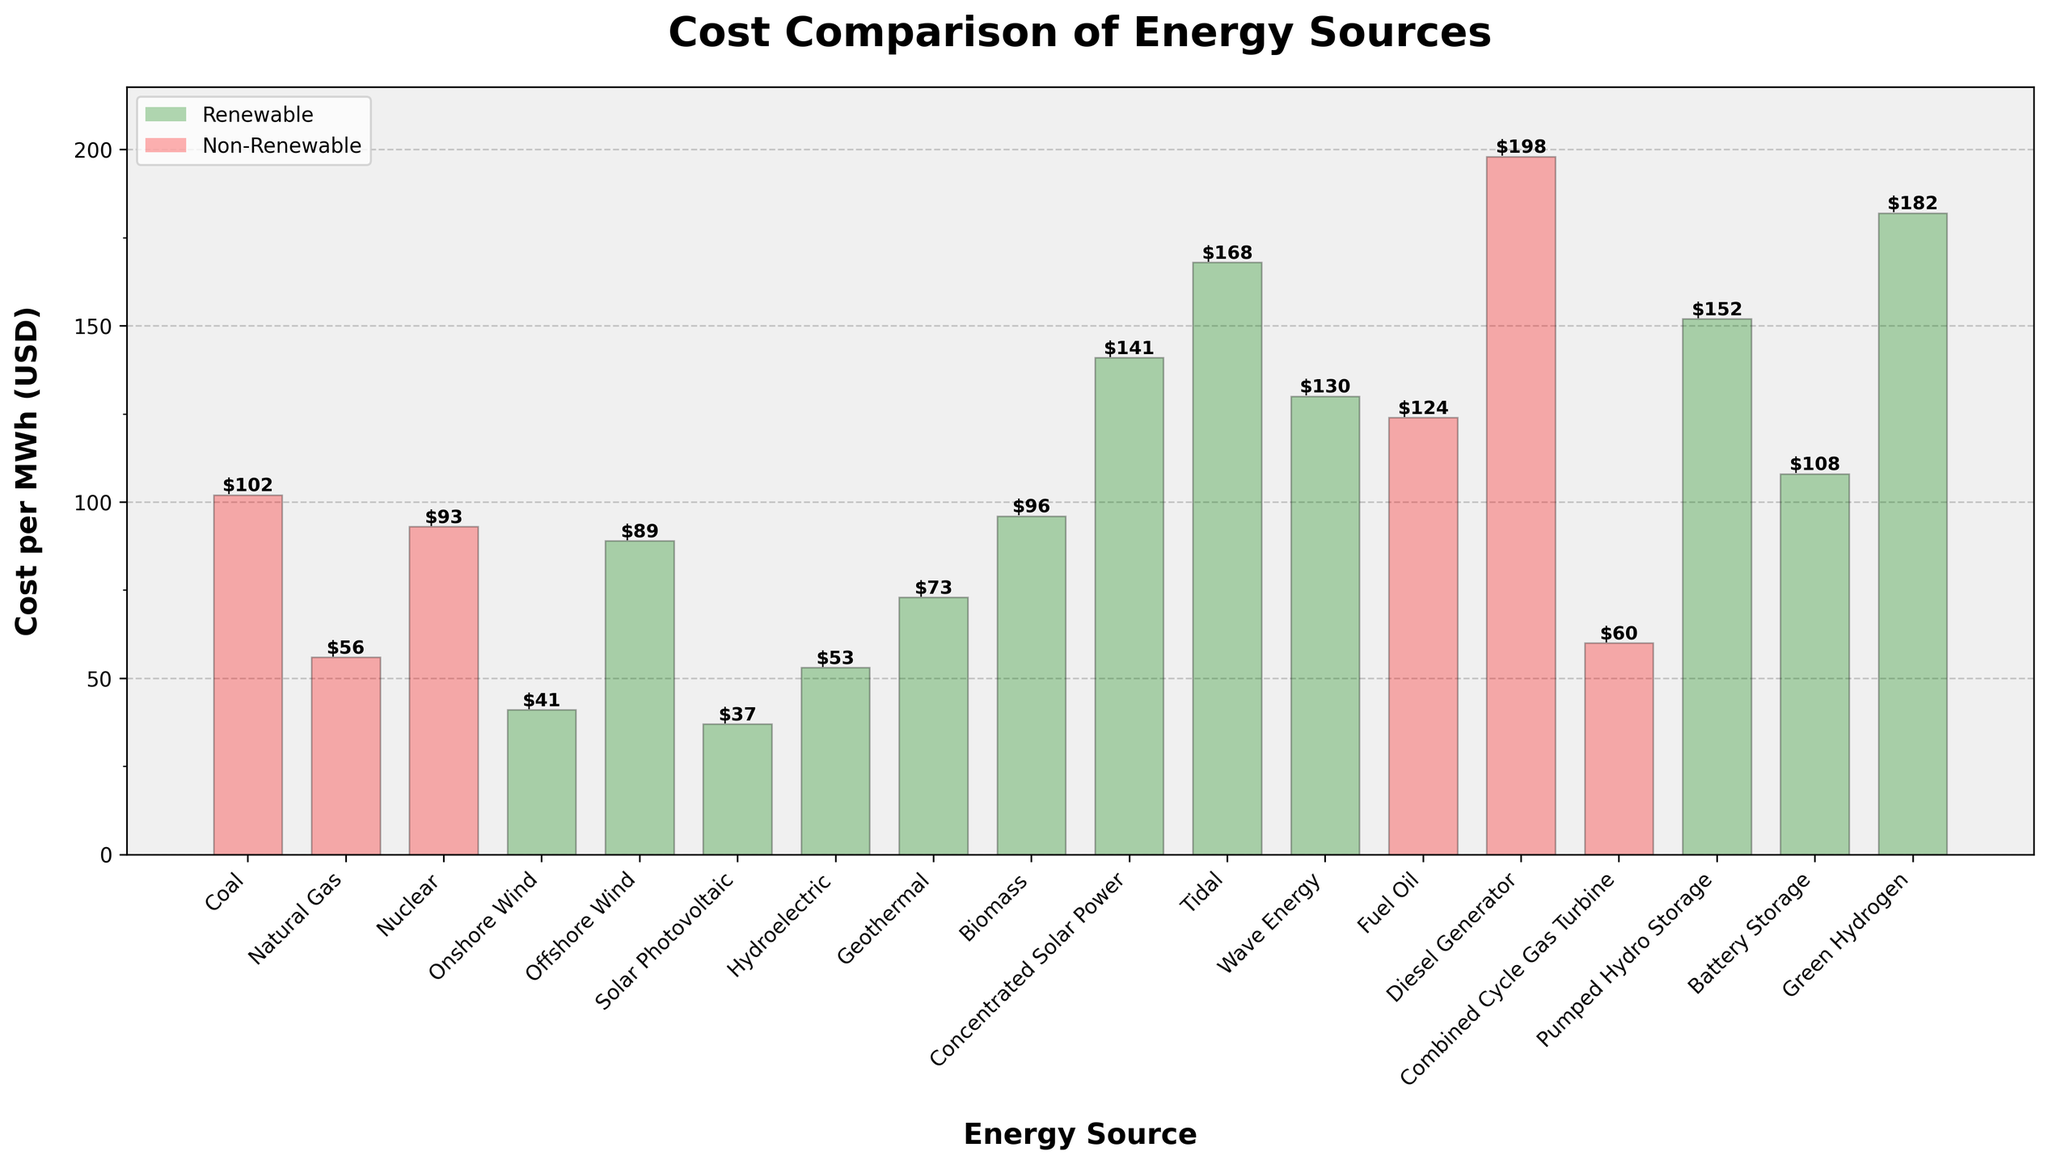Which energy source has the lowest cost per MWh? The lowest bar on the chart indicates the cost for Solar Photovoltaic.
Answer: Solar Photovoltaic Which energy sources are classified as non-renewable in the chart? The bars colored in red represent non-renewable energy sources: Coal, Natural Gas, Nuclear, Fuel Oil, Diesel Generator, and Combined Cycle Gas Turbine.
Answer: Coal, Natural Gas, Nuclear, Fuel Oil, Diesel Generator, Combined Cycle Gas Turbine What is the cost difference between the most expensive and the least expensive energy sources? The highest bar shows Tidal at $168 per MWh and the lowest shows Solar Photovoltaic at $37 per MWh. So, the difference is $168 - $37.
Answer: $131 Which renewable energy source has the highest cost per MWh? Among the green bars, Wave Energy has the highest cost per MWh at $130.
Answer: Wave Energy How many energy sources have a cost higher than $100 per MWh? Counting the bars exceeding the $100 line: Coal, Tidal, Diesel Generator, Fuel Oil, Battery Storage, Pumped Hydro Storage, and Green Hydrogen. There are 7 bars.
Answer: 7 What is the combined cost of Onshore Wind, Solar Photovoltaic, and Hydroelectric energy sources per MWh? Sum their costs: Onshore Wind ($41), Solar Photovoltaic ($37), and Hydroelectric ($53). Adding these: 41 + 37 + 53 = 131.
Answer: $131 Which energy source is more expensive: Biomass or Nuclear? Comparing the height of the corresponding bars, Nuclear at $93 is less than Biomass at $96. So, Biomass is more expensive.
Answer: Biomass What is the average cost per MWh of all renewable energy sources listed? Renewable energy sources include: Onshore Wind ($41), Offshore Wind ($89), Solar Photovoltaic ($37), Hydroelectric ($53), Geothermal ($73), Biomass ($96), Concentrated Solar Power ($141), Tidal ($168), Wave Energy ($130), Pumped Hydro Storage ($152), and Green Hydrogen ($182). Sum these costs: 41 + 89 + 37 + 53 + 73 + 96 + 141 + 168 + 130 + 152 + 182 = 1162. There are 11 sources, so divide the sum by 11: 1162 / 11 ≈ 105.64.
Answer: $105.64 Between Natural Gas and Combined Cycle Gas Turbine, which is cheaper per MWh? The height of Natural Gas bar is $56 while Combined Cycle Gas Turbine is $60. Natural Gas is cheaper.
Answer: Natural Gas What proportion of the energy sources listed have a cost per MWh lower than $70? To find the proportion, count the bars below $70: Solar Photovoltaic, Onshore Wind, and Hydroelectric. There are 3 out of 18 sources, so the proportion is 3/18 which simplifies to 1/6.
Answer: 1/6 